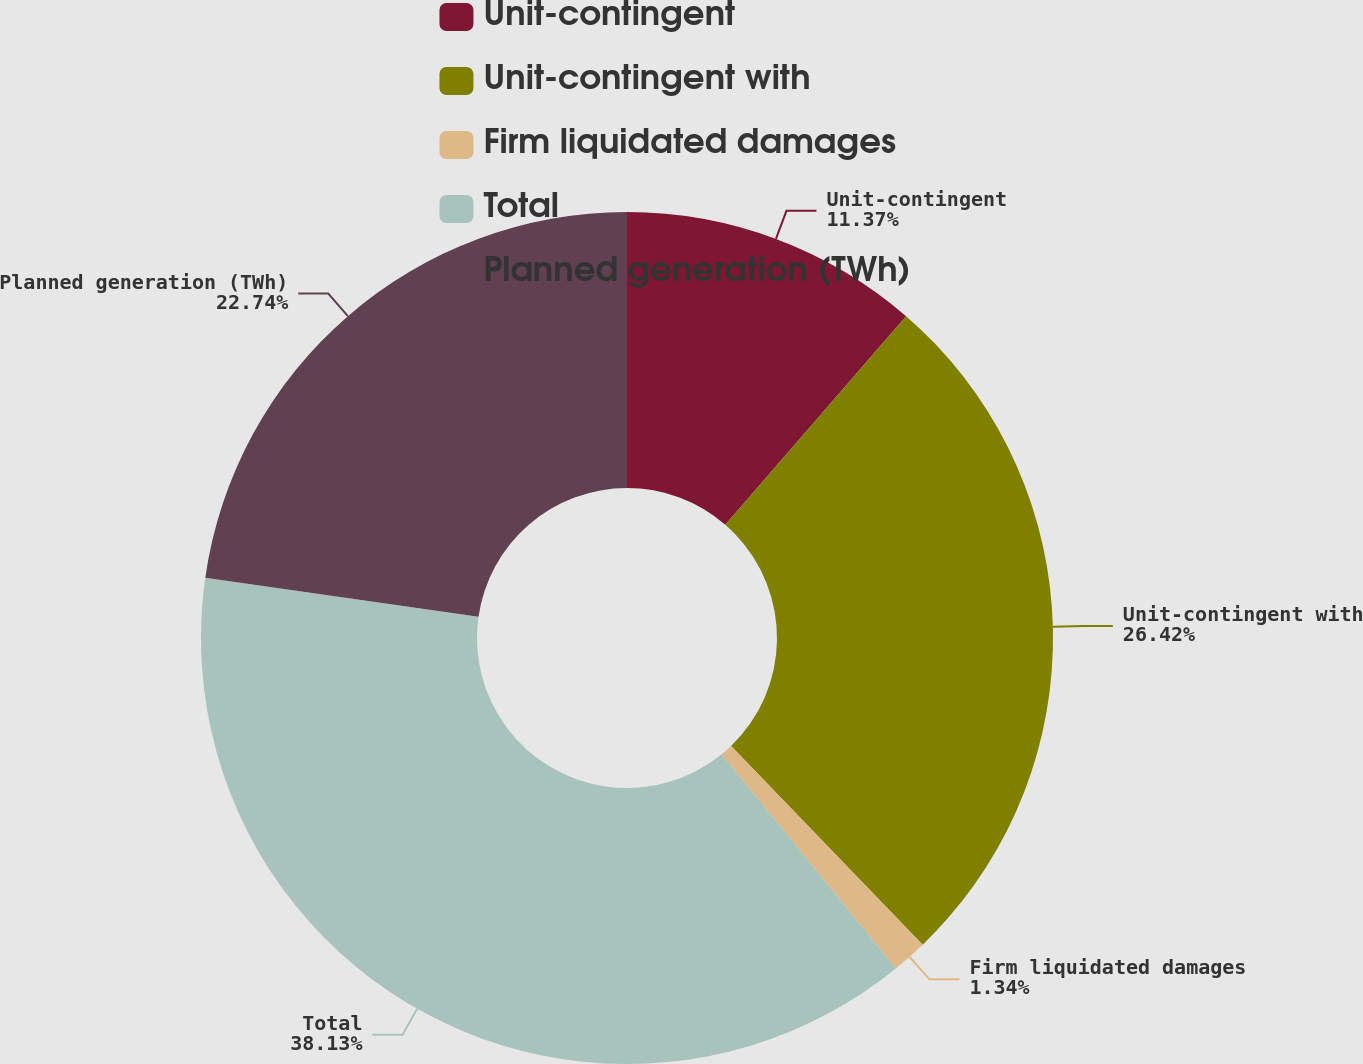Convert chart. <chart><loc_0><loc_0><loc_500><loc_500><pie_chart><fcel>Unit-contingent<fcel>Unit-contingent with<fcel>Firm liquidated damages<fcel>Total<fcel>Planned generation (TWh)<nl><fcel>11.37%<fcel>26.42%<fcel>1.34%<fcel>38.13%<fcel>22.74%<nl></chart> 